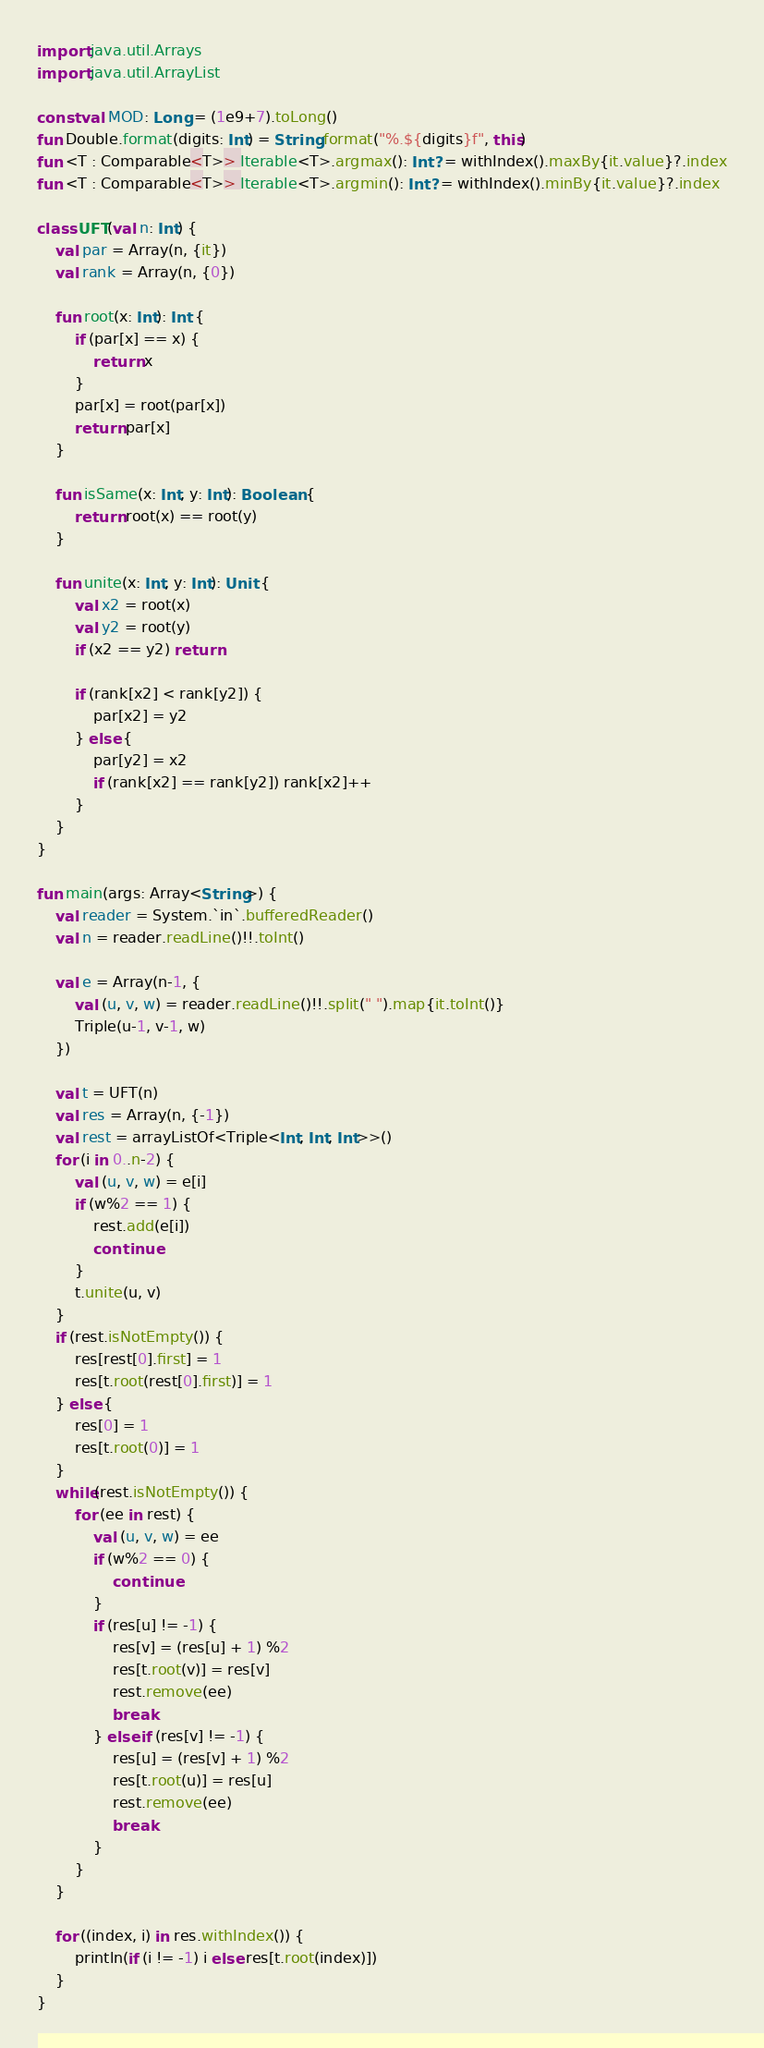Convert code to text. <code><loc_0><loc_0><loc_500><loc_500><_Kotlin_>import java.util.Arrays
import java.util.ArrayList

const val MOD: Long = (1e9+7).toLong()
fun Double.format(digits: Int) = String.format("%.${digits}f", this)
fun <T : Comparable<T>> Iterable<T>.argmax(): Int? = withIndex().maxBy{it.value}?.index
fun <T : Comparable<T>> Iterable<T>.argmin(): Int? = withIndex().minBy{it.value}?.index

class UFT(val n: Int) {
    val par = Array(n, {it})
    val rank = Array(n, {0})

    fun root(x: Int): Int {
        if (par[x] == x) {
            return x
        }
        par[x] = root(par[x])
        return par[x]
    }

    fun isSame(x: Int, y: Int): Boolean {
        return root(x) == root(y)
    }

    fun unite(x: Int, y: Int): Unit {
        val x2 = root(x)
        val y2 = root(y)
        if (x2 == y2) return

        if (rank[x2] < rank[y2]) {
            par[x2] = y2
        } else {
            par[y2] = x2
            if (rank[x2] == rank[y2]) rank[x2]++
        }
    }
}

fun main(args: Array<String>) {
    val reader = System.`in`.bufferedReader()
    val n = reader.readLine()!!.toInt()

    val e = Array(n-1, {
        val (u, v, w) = reader.readLine()!!.split(" ").map{it.toInt()}
        Triple(u-1, v-1, w)
    })

    val t = UFT(n)
    val res = Array(n, {-1})
    val rest = arrayListOf<Triple<Int, Int, Int>>()
    for (i in 0..n-2) {
        val (u, v, w) = e[i]
        if (w%2 == 1) {
            rest.add(e[i])
            continue
        }
        t.unite(u, v)
    }
    if (rest.isNotEmpty()) {
        res[rest[0].first] = 1
        res[t.root(rest[0].first)] = 1
    } else {
        res[0] = 1
        res[t.root(0)] = 1
    }
    while(rest.isNotEmpty()) {
        for (ee in rest) {
            val (u, v, w) = ee
            if (w%2 == 0) {
                continue
            }
            if (res[u] != -1) {
                res[v] = (res[u] + 1) %2
                res[t.root(v)] = res[v]
                rest.remove(ee)
                break
            } else if (res[v] != -1) {
                res[u] = (res[v] + 1) %2
                res[t.root(u)] = res[u]
                rest.remove(ee)
                break
            }
        }
    }

    for ((index, i) in res.withIndex()) {
        println(if (i != -1) i else res[t.root(index)])
    }
}
</code> 